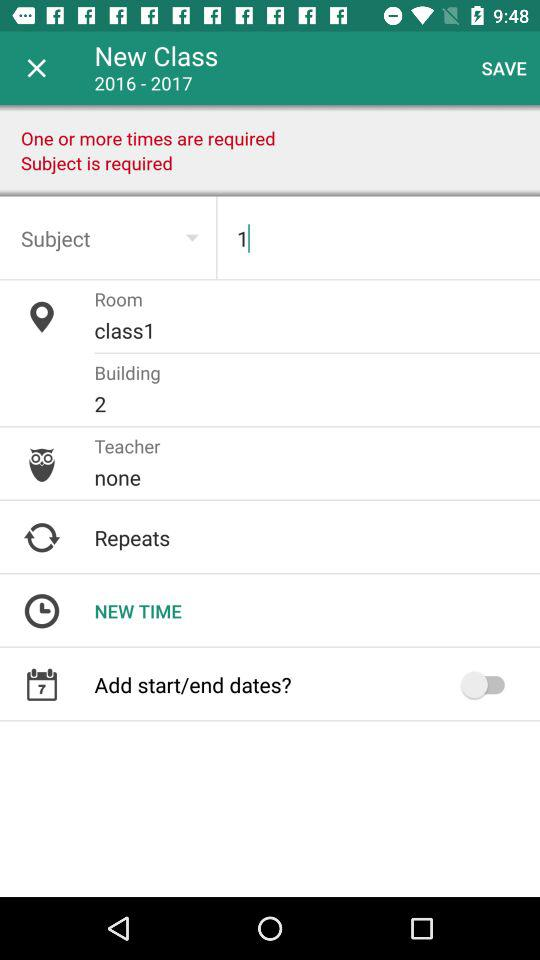What is the subject name? The subject name is "1". 